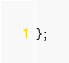Convert code to text. <code><loc_0><loc_0><loc_500><loc_500><_Haxe_>};
</code> 